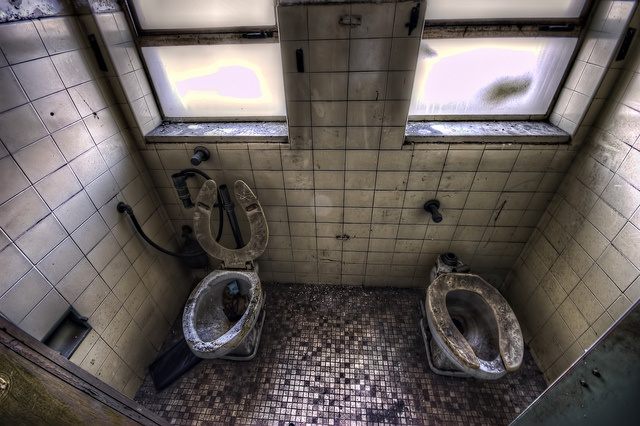Describe the objects in this image and their specific colors. I can see toilet in gray and black tones and toilet in gray, black, and darkgray tones in this image. 